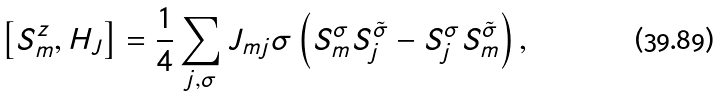Convert formula to latex. <formula><loc_0><loc_0><loc_500><loc_500>\left [ S ^ { z } _ { m } , H _ { J } \right ] = \frac { 1 } { 4 } \sum _ { j , \sigma } J _ { m j } \sigma \left ( S _ { m } ^ { \sigma } S _ { j } ^ { \tilde { \sigma } } - S _ { j } ^ { \sigma } S _ { m } ^ { \tilde { \sigma } } \right ) ,</formula> 